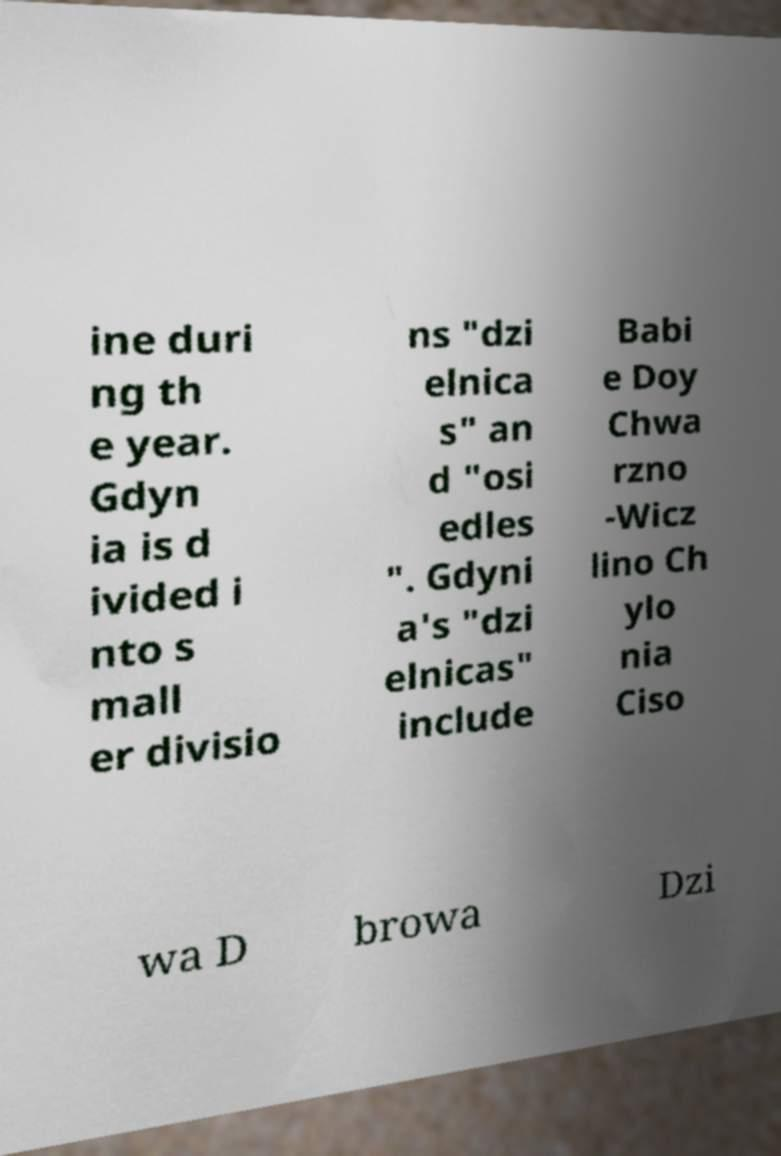I need the written content from this picture converted into text. Can you do that? ine duri ng th e year. Gdyn ia is d ivided i nto s mall er divisio ns "dzi elnica s" an d "osi edles ". Gdyni a's "dzi elnicas" include Babi e Doy Chwa rzno -Wicz lino Ch ylo nia Ciso wa D browa Dzi 